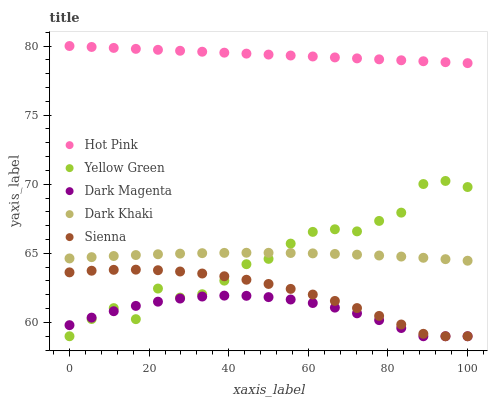Does Dark Magenta have the minimum area under the curve?
Answer yes or no. Yes. Does Hot Pink have the maximum area under the curve?
Answer yes or no. Yes. Does Sienna have the minimum area under the curve?
Answer yes or no. No. Does Sienna have the maximum area under the curve?
Answer yes or no. No. Is Hot Pink the smoothest?
Answer yes or no. Yes. Is Yellow Green the roughest?
Answer yes or no. Yes. Is Sienna the smoothest?
Answer yes or no. No. Is Sienna the roughest?
Answer yes or no. No. Does Sienna have the lowest value?
Answer yes or no. Yes. Does Hot Pink have the lowest value?
Answer yes or no. No. Does Hot Pink have the highest value?
Answer yes or no. Yes. Does Sienna have the highest value?
Answer yes or no. No. Is Dark Magenta less than Hot Pink?
Answer yes or no. Yes. Is Hot Pink greater than Sienna?
Answer yes or no. Yes. Does Dark Magenta intersect Yellow Green?
Answer yes or no. Yes. Is Dark Magenta less than Yellow Green?
Answer yes or no. No. Is Dark Magenta greater than Yellow Green?
Answer yes or no. No. Does Dark Magenta intersect Hot Pink?
Answer yes or no. No. 